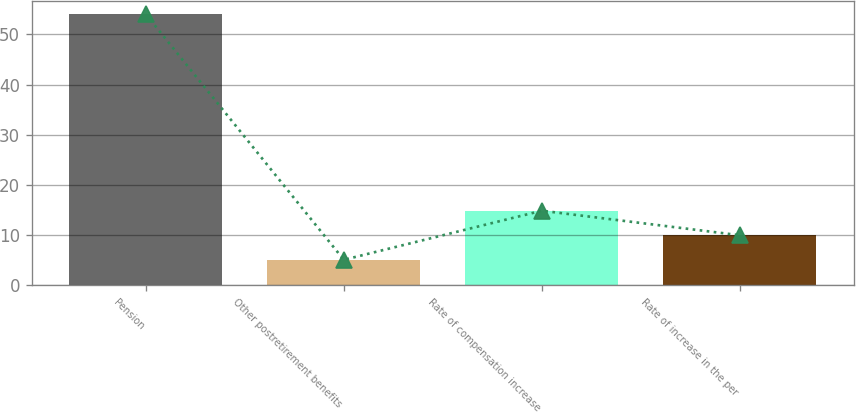Convert chart to OTSL. <chart><loc_0><loc_0><loc_500><loc_500><bar_chart><fcel>Pension<fcel>Other postretirement benefits<fcel>Rate of compensation increase<fcel>Rate of increase in the per<nl><fcel>54<fcel>5.1<fcel>14.88<fcel>9.99<nl></chart> 